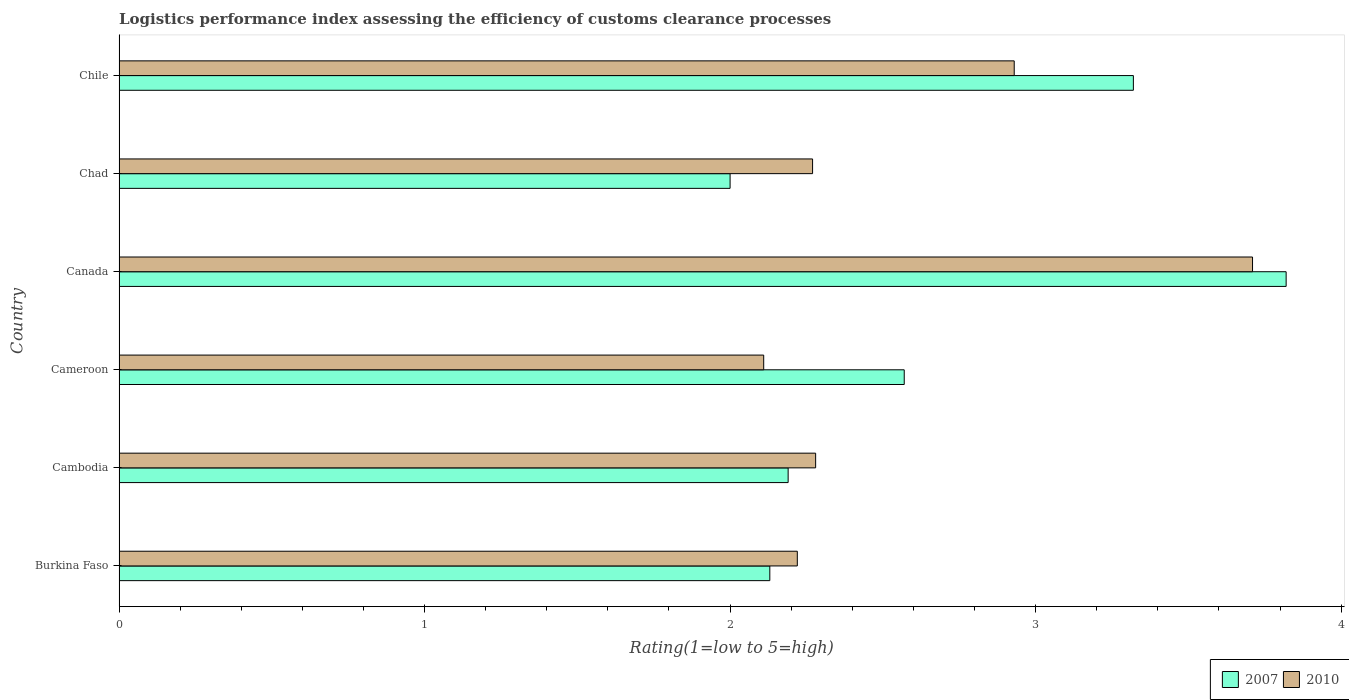How many different coloured bars are there?
Keep it short and to the point. 2. Are the number of bars per tick equal to the number of legend labels?
Your answer should be very brief. Yes. How many bars are there on the 5th tick from the bottom?
Offer a very short reply. 2. What is the label of the 2nd group of bars from the top?
Your answer should be very brief. Chad. What is the Logistic performance index in 2010 in Cambodia?
Provide a succinct answer. 2.28. Across all countries, what is the maximum Logistic performance index in 2007?
Make the answer very short. 3.82. Across all countries, what is the minimum Logistic performance index in 2007?
Your answer should be very brief. 2. In which country was the Logistic performance index in 2010 minimum?
Provide a succinct answer. Cameroon. What is the total Logistic performance index in 2007 in the graph?
Provide a short and direct response. 16.03. What is the difference between the Logistic performance index in 2010 in Cambodia and that in Chad?
Keep it short and to the point. 0.01. What is the difference between the Logistic performance index in 2010 in Chad and the Logistic performance index in 2007 in Burkina Faso?
Keep it short and to the point. 0.14. What is the average Logistic performance index in 2007 per country?
Your answer should be compact. 2.67. What is the difference between the Logistic performance index in 2010 and Logistic performance index in 2007 in Chad?
Your answer should be compact. 0.27. In how many countries, is the Logistic performance index in 2010 greater than 2.4 ?
Provide a short and direct response. 2. What is the ratio of the Logistic performance index in 2007 in Burkina Faso to that in Chile?
Your answer should be compact. 0.64. Is the Logistic performance index in 2007 in Burkina Faso less than that in Cameroon?
Provide a short and direct response. Yes. Is the difference between the Logistic performance index in 2010 in Cameroon and Chile greater than the difference between the Logistic performance index in 2007 in Cameroon and Chile?
Your response must be concise. No. In how many countries, is the Logistic performance index in 2007 greater than the average Logistic performance index in 2007 taken over all countries?
Offer a terse response. 2. What does the 1st bar from the top in Cambodia represents?
Provide a short and direct response. 2010. What does the 2nd bar from the bottom in Cameroon represents?
Provide a short and direct response. 2010. How many countries are there in the graph?
Provide a succinct answer. 6. Are the values on the major ticks of X-axis written in scientific E-notation?
Your response must be concise. No. Does the graph contain any zero values?
Your answer should be compact. No. Where does the legend appear in the graph?
Offer a terse response. Bottom right. What is the title of the graph?
Make the answer very short. Logistics performance index assessing the efficiency of customs clearance processes. What is the label or title of the X-axis?
Your answer should be very brief. Rating(1=low to 5=high). What is the Rating(1=low to 5=high) of 2007 in Burkina Faso?
Make the answer very short. 2.13. What is the Rating(1=low to 5=high) of 2010 in Burkina Faso?
Ensure brevity in your answer.  2.22. What is the Rating(1=low to 5=high) of 2007 in Cambodia?
Offer a terse response. 2.19. What is the Rating(1=low to 5=high) of 2010 in Cambodia?
Provide a succinct answer. 2.28. What is the Rating(1=low to 5=high) in 2007 in Cameroon?
Offer a terse response. 2.57. What is the Rating(1=low to 5=high) of 2010 in Cameroon?
Make the answer very short. 2.11. What is the Rating(1=low to 5=high) in 2007 in Canada?
Provide a succinct answer. 3.82. What is the Rating(1=low to 5=high) of 2010 in Canada?
Offer a terse response. 3.71. What is the Rating(1=low to 5=high) in 2007 in Chad?
Offer a terse response. 2. What is the Rating(1=low to 5=high) in 2010 in Chad?
Make the answer very short. 2.27. What is the Rating(1=low to 5=high) of 2007 in Chile?
Keep it short and to the point. 3.32. What is the Rating(1=low to 5=high) of 2010 in Chile?
Offer a very short reply. 2.93. Across all countries, what is the maximum Rating(1=low to 5=high) in 2007?
Your answer should be very brief. 3.82. Across all countries, what is the maximum Rating(1=low to 5=high) in 2010?
Provide a succinct answer. 3.71. Across all countries, what is the minimum Rating(1=low to 5=high) in 2010?
Keep it short and to the point. 2.11. What is the total Rating(1=low to 5=high) in 2007 in the graph?
Your response must be concise. 16.03. What is the total Rating(1=low to 5=high) in 2010 in the graph?
Offer a terse response. 15.52. What is the difference between the Rating(1=low to 5=high) of 2007 in Burkina Faso and that in Cambodia?
Ensure brevity in your answer.  -0.06. What is the difference between the Rating(1=low to 5=high) of 2010 in Burkina Faso and that in Cambodia?
Your response must be concise. -0.06. What is the difference between the Rating(1=low to 5=high) in 2007 in Burkina Faso and that in Cameroon?
Give a very brief answer. -0.44. What is the difference between the Rating(1=low to 5=high) of 2010 in Burkina Faso and that in Cameroon?
Give a very brief answer. 0.11. What is the difference between the Rating(1=low to 5=high) of 2007 in Burkina Faso and that in Canada?
Ensure brevity in your answer.  -1.69. What is the difference between the Rating(1=low to 5=high) in 2010 in Burkina Faso and that in Canada?
Give a very brief answer. -1.49. What is the difference between the Rating(1=low to 5=high) of 2007 in Burkina Faso and that in Chad?
Your answer should be compact. 0.13. What is the difference between the Rating(1=low to 5=high) of 2007 in Burkina Faso and that in Chile?
Offer a terse response. -1.19. What is the difference between the Rating(1=low to 5=high) in 2010 in Burkina Faso and that in Chile?
Provide a short and direct response. -0.71. What is the difference between the Rating(1=low to 5=high) in 2007 in Cambodia and that in Cameroon?
Make the answer very short. -0.38. What is the difference between the Rating(1=low to 5=high) of 2010 in Cambodia and that in Cameroon?
Provide a short and direct response. 0.17. What is the difference between the Rating(1=low to 5=high) in 2007 in Cambodia and that in Canada?
Ensure brevity in your answer.  -1.63. What is the difference between the Rating(1=low to 5=high) in 2010 in Cambodia and that in Canada?
Your answer should be compact. -1.43. What is the difference between the Rating(1=low to 5=high) in 2007 in Cambodia and that in Chad?
Ensure brevity in your answer.  0.19. What is the difference between the Rating(1=low to 5=high) in 2007 in Cambodia and that in Chile?
Give a very brief answer. -1.13. What is the difference between the Rating(1=low to 5=high) in 2010 in Cambodia and that in Chile?
Your answer should be compact. -0.65. What is the difference between the Rating(1=low to 5=high) in 2007 in Cameroon and that in Canada?
Offer a very short reply. -1.25. What is the difference between the Rating(1=low to 5=high) of 2010 in Cameroon and that in Canada?
Ensure brevity in your answer.  -1.6. What is the difference between the Rating(1=low to 5=high) of 2007 in Cameroon and that in Chad?
Ensure brevity in your answer.  0.57. What is the difference between the Rating(1=low to 5=high) of 2010 in Cameroon and that in Chad?
Provide a short and direct response. -0.16. What is the difference between the Rating(1=low to 5=high) of 2007 in Cameroon and that in Chile?
Your answer should be compact. -0.75. What is the difference between the Rating(1=low to 5=high) in 2010 in Cameroon and that in Chile?
Make the answer very short. -0.82. What is the difference between the Rating(1=low to 5=high) in 2007 in Canada and that in Chad?
Your answer should be compact. 1.82. What is the difference between the Rating(1=low to 5=high) of 2010 in Canada and that in Chad?
Give a very brief answer. 1.44. What is the difference between the Rating(1=low to 5=high) of 2010 in Canada and that in Chile?
Keep it short and to the point. 0.78. What is the difference between the Rating(1=low to 5=high) in 2007 in Chad and that in Chile?
Your answer should be compact. -1.32. What is the difference between the Rating(1=low to 5=high) of 2010 in Chad and that in Chile?
Provide a succinct answer. -0.66. What is the difference between the Rating(1=low to 5=high) in 2007 in Burkina Faso and the Rating(1=low to 5=high) in 2010 in Cambodia?
Provide a succinct answer. -0.15. What is the difference between the Rating(1=low to 5=high) of 2007 in Burkina Faso and the Rating(1=low to 5=high) of 2010 in Canada?
Offer a very short reply. -1.58. What is the difference between the Rating(1=low to 5=high) of 2007 in Burkina Faso and the Rating(1=low to 5=high) of 2010 in Chad?
Offer a very short reply. -0.14. What is the difference between the Rating(1=low to 5=high) in 2007 in Burkina Faso and the Rating(1=low to 5=high) in 2010 in Chile?
Your answer should be very brief. -0.8. What is the difference between the Rating(1=low to 5=high) in 2007 in Cambodia and the Rating(1=low to 5=high) in 2010 in Canada?
Your answer should be compact. -1.52. What is the difference between the Rating(1=low to 5=high) in 2007 in Cambodia and the Rating(1=low to 5=high) in 2010 in Chad?
Give a very brief answer. -0.08. What is the difference between the Rating(1=low to 5=high) of 2007 in Cambodia and the Rating(1=low to 5=high) of 2010 in Chile?
Provide a short and direct response. -0.74. What is the difference between the Rating(1=low to 5=high) of 2007 in Cameroon and the Rating(1=low to 5=high) of 2010 in Canada?
Provide a short and direct response. -1.14. What is the difference between the Rating(1=low to 5=high) of 2007 in Cameroon and the Rating(1=low to 5=high) of 2010 in Chile?
Provide a succinct answer. -0.36. What is the difference between the Rating(1=low to 5=high) of 2007 in Canada and the Rating(1=low to 5=high) of 2010 in Chad?
Your response must be concise. 1.55. What is the difference between the Rating(1=low to 5=high) in 2007 in Canada and the Rating(1=low to 5=high) in 2010 in Chile?
Your response must be concise. 0.89. What is the difference between the Rating(1=low to 5=high) in 2007 in Chad and the Rating(1=low to 5=high) in 2010 in Chile?
Keep it short and to the point. -0.93. What is the average Rating(1=low to 5=high) in 2007 per country?
Provide a succinct answer. 2.67. What is the average Rating(1=low to 5=high) in 2010 per country?
Your response must be concise. 2.59. What is the difference between the Rating(1=low to 5=high) of 2007 and Rating(1=low to 5=high) of 2010 in Burkina Faso?
Your answer should be very brief. -0.09. What is the difference between the Rating(1=low to 5=high) of 2007 and Rating(1=low to 5=high) of 2010 in Cambodia?
Provide a short and direct response. -0.09. What is the difference between the Rating(1=low to 5=high) of 2007 and Rating(1=low to 5=high) of 2010 in Cameroon?
Offer a very short reply. 0.46. What is the difference between the Rating(1=low to 5=high) of 2007 and Rating(1=low to 5=high) of 2010 in Canada?
Make the answer very short. 0.11. What is the difference between the Rating(1=low to 5=high) in 2007 and Rating(1=low to 5=high) in 2010 in Chad?
Keep it short and to the point. -0.27. What is the difference between the Rating(1=low to 5=high) in 2007 and Rating(1=low to 5=high) in 2010 in Chile?
Your answer should be very brief. 0.39. What is the ratio of the Rating(1=low to 5=high) in 2007 in Burkina Faso to that in Cambodia?
Provide a short and direct response. 0.97. What is the ratio of the Rating(1=low to 5=high) of 2010 in Burkina Faso to that in Cambodia?
Your answer should be very brief. 0.97. What is the ratio of the Rating(1=low to 5=high) of 2007 in Burkina Faso to that in Cameroon?
Offer a very short reply. 0.83. What is the ratio of the Rating(1=low to 5=high) in 2010 in Burkina Faso to that in Cameroon?
Give a very brief answer. 1.05. What is the ratio of the Rating(1=low to 5=high) in 2007 in Burkina Faso to that in Canada?
Keep it short and to the point. 0.56. What is the ratio of the Rating(1=low to 5=high) of 2010 in Burkina Faso to that in Canada?
Offer a terse response. 0.6. What is the ratio of the Rating(1=low to 5=high) of 2007 in Burkina Faso to that in Chad?
Ensure brevity in your answer.  1.06. What is the ratio of the Rating(1=low to 5=high) in 2007 in Burkina Faso to that in Chile?
Your answer should be very brief. 0.64. What is the ratio of the Rating(1=low to 5=high) of 2010 in Burkina Faso to that in Chile?
Your answer should be very brief. 0.76. What is the ratio of the Rating(1=low to 5=high) in 2007 in Cambodia to that in Cameroon?
Your response must be concise. 0.85. What is the ratio of the Rating(1=low to 5=high) of 2010 in Cambodia to that in Cameroon?
Keep it short and to the point. 1.08. What is the ratio of the Rating(1=low to 5=high) in 2007 in Cambodia to that in Canada?
Keep it short and to the point. 0.57. What is the ratio of the Rating(1=low to 5=high) in 2010 in Cambodia to that in Canada?
Keep it short and to the point. 0.61. What is the ratio of the Rating(1=low to 5=high) of 2007 in Cambodia to that in Chad?
Provide a short and direct response. 1.09. What is the ratio of the Rating(1=low to 5=high) in 2010 in Cambodia to that in Chad?
Your answer should be very brief. 1. What is the ratio of the Rating(1=low to 5=high) in 2007 in Cambodia to that in Chile?
Ensure brevity in your answer.  0.66. What is the ratio of the Rating(1=low to 5=high) in 2010 in Cambodia to that in Chile?
Your answer should be very brief. 0.78. What is the ratio of the Rating(1=low to 5=high) of 2007 in Cameroon to that in Canada?
Your answer should be compact. 0.67. What is the ratio of the Rating(1=low to 5=high) of 2010 in Cameroon to that in Canada?
Provide a short and direct response. 0.57. What is the ratio of the Rating(1=low to 5=high) of 2007 in Cameroon to that in Chad?
Ensure brevity in your answer.  1.28. What is the ratio of the Rating(1=low to 5=high) in 2010 in Cameroon to that in Chad?
Make the answer very short. 0.93. What is the ratio of the Rating(1=low to 5=high) in 2007 in Cameroon to that in Chile?
Offer a very short reply. 0.77. What is the ratio of the Rating(1=low to 5=high) in 2010 in Cameroon to that in Chile?
Your answer should be compact. 0.72. What is the ratio of the Rating(1=low to 5=high) in 2007 in Canada to that in Chad?
Offer a terse response. 1.91. What is the ratio of the Rating(1=low to 5=high) in 2010 in Canada to that in Chad?
Your answer should be compact. 1.63. What is the ratio of the Rating(1=low to 5=high) in 2007 in Canada to that in Chile?
Provide a short and direct response. 1.15. What is the ratio of the Rating(1=low to 5=high) of 2010 in Canada to that in Chile?
Your answer should be compact. 1.27. What is the ratio of the Rating(1=low to 5=high) in 2007 in Chad to that in Chile?
Offer a very short reply. 0.6. What is the ratio of the Rating(1=low to 5=high) of 2010 in Chad to that in Chile?
Your response must be concise. 0.77. What is the difference between the highest and the second highest Rating(1=low to 5=high) in 2010?
Ensure brevity in your answer.  0.78. What is the difference between the highest and the lowest Rating(1=low to 5=high) of 2007?
Keep it short and to the point. 1.82. What is the difference between the highest and the lowest Rating(1=low to 5=high) of 2010?
Ensure brevity in your answer.  1.6. 